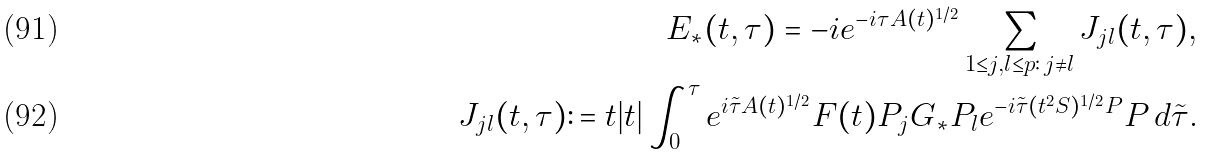Convert formula to latex. <formula><loc_0><loc_0><loc_500><loc_500>E _ { * } ( t , \tau ) = - i e ^ { - i \tau A ( t ) ^ { 1 / 2 } } \sum _ { 1 \leq j , l \leq p \colon \, j \ne l } J _ { j l } ( t , \tau ) , \\ J _ { j l } ( t , \tau ) \colon = t | t | \int _ { 0 } ^ { \tau } e ^ { i \tilde { \tau } A ( t ) ^ { 1 / 2 } } F ( t ) P _ { j } G _ { * } P _ { l } e ^ { - i \tilde { \tau } ( t ^ { 2 } S ) ^ { 1 / 2 } P } P \, d \tilde { \tau } .</formula> 